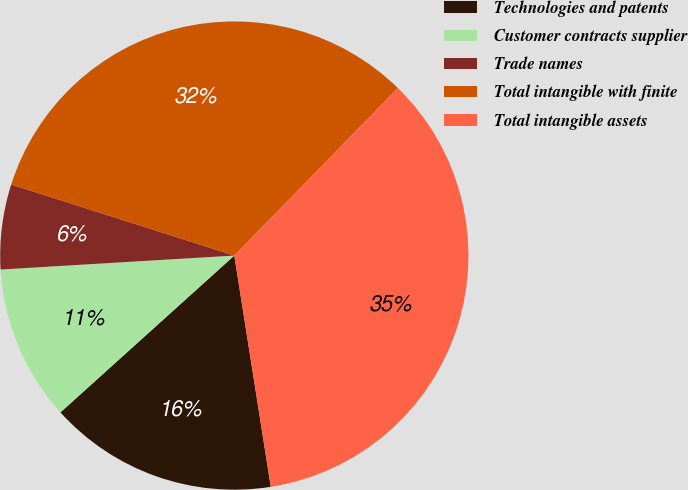Convert chart to OTSL. <chart><loc_0><loc_0><loc_500><loc_500><pie_chart><fcel>Technologies and patents<fcel>Customer contracts supplier<fcel>Trade names<fcel>Total intangible with finite<fcel>Total intangible assets<nl><fcel>15.81%<fcel>10.73%<fcel>5.86%<fcel>32.4%<fcel>35.2%<nl></chart> 